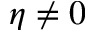Convert formula to latex. <formula><loc_0><loc_0><loc_500><loc_500>\eta \neq 0</formula> 